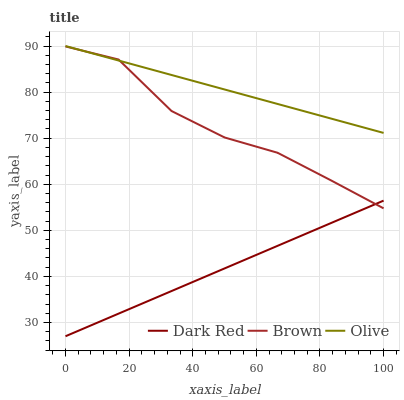Does Dark Red have the minimum area under the curve?
Answer yes or no. Yes. Does Olive have the maximum area under the curve?
Answer yes or no. Yes. Does Brown have the minimum area under the curve?
Answer yes or no. No. Does Brown have the maximum area under the curve?
Answer yes or no. No. Is Dark Red the smoothest?
Answer yes or no. Yes. Is Brown the roughest?
Answer yes or no. Yes. Is Brown the smoothest?
Answer yes or no. No. Is Dark Red the roughest?
Answer yes or no. No. Does Dark Red have the lowest value?
Answer yes or no. Yes. Does Brown have the lowest value?
Answer yes or no. No. Does Olive have the highest value?
Answer yes or no. Yes. Does Brown have the highest value?
Answer yes or no. No. Is Dark Red less than Olive?
Answer yes or no. Yes. Is Olive greater than Dark Red?
Answer yes or no. Yes. Does Brown intersect Dark Red?
Answer yes or no. Yes. Is Brown less than Dark Red?
Answer yes or no. No. Is Brown greater than Dark Red?
Answer yes or no. No. Does Dark Red intersect Olive?
Answer yes or no. No. 